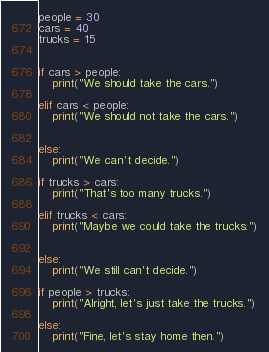<code> <loc_0><loc_0><loc_500><loc_500><_Python_>people = 30
cars = 40
trucks = 15


if cars > people:
    print("We should take the cars.")

elif cars < people:
    print("We should not take the cars.")


else:
    print("We can't decide.")

if trucks > cars:
    print("That's too many trucks.")

elif trucks < cars:
    print("Maybe we could take the trucks.")


else:
    print("We still can't decide.")

if people > trucks:
    print("Alright, let's just take the trucks.")

else:
    print("Fine, let's stay home then.")

</code> 